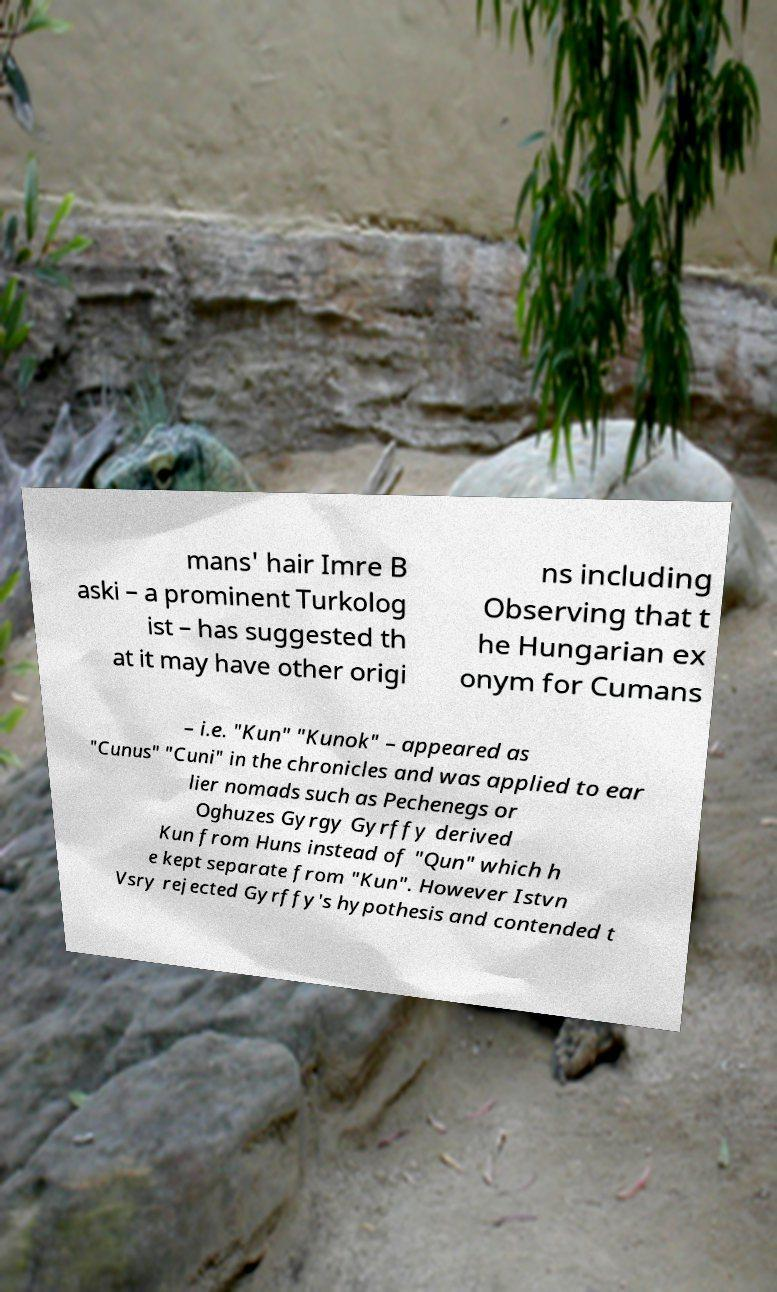For documentation purposes, I need the text within this image transcribed. Could you provide that? mans' hair Imre B aski – a prominent Turkolog ist – has suggested th at it may have other origi ns including Observing that t he Hungarian ex onym for Cumans – i.e. "Kun" "Kunok" – appeared as "Cunus" "Cuni" in the chronicles and was applied to ear lier nomads such as Pechenegs or Oghuzes Gyrgy Gyrffy derived Kun from Huns instead of "Qun" which h e kept separate from "Kun". However Istvn Vsry rejected Gyrffy's hypothesis and contended t 